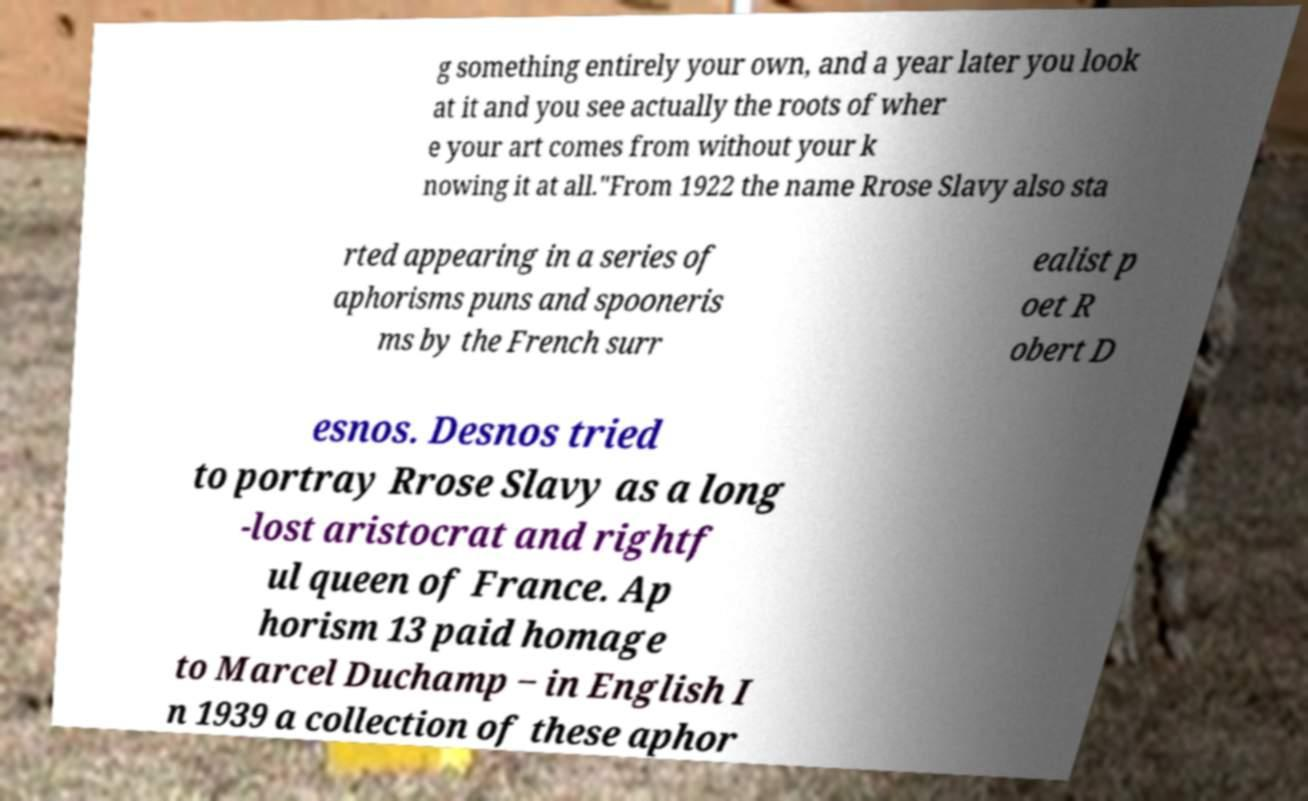Could you extract and type out the text from this image? g something entirely your own, and a year later you look at it and you see actually the roots of wher e your art comes from without your k nowing it at all."From 1922 the name Rrose Slavy also sta rted appearing in a series of aphorisms puns and spooneris ms by the French surr ealist p oet R obert D esnos. Desnos tried to portray Rrose Slavy as a long -lost aristocrat and rightf ul queen of France. Ap horism 13 paid homage to Marcel Duchamp ‒ in English I n 1939 a collection of these aphor 